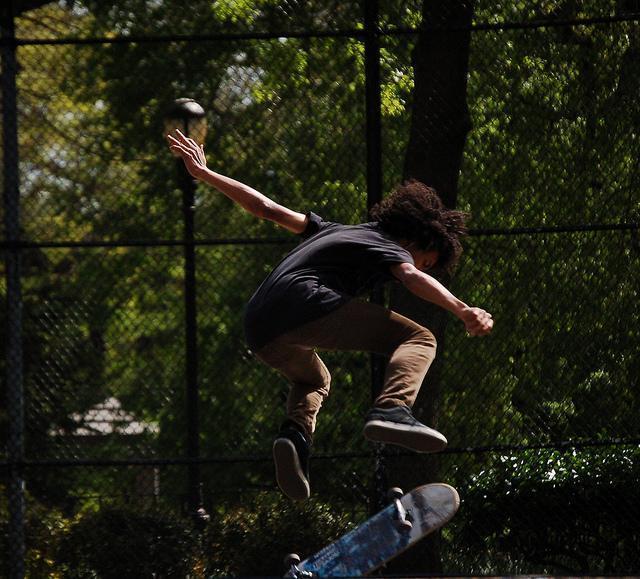How many white trucks are there in the image ?
Give a very brief answer. 0. 